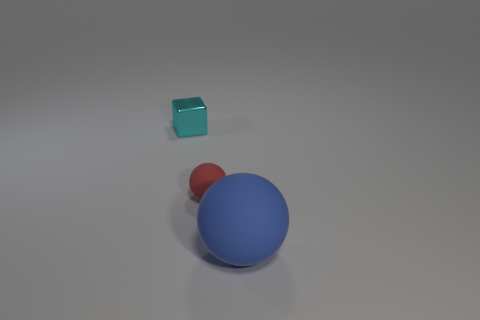Is there any other thing that is the same size as the blue object?
Give a very brief answer. No. What number of objects are small objects in front of the metallic thing or small things that are right of the cyan metal block?
Your answer should be very brief. 1. There is a red rubber thing; what shape is it?
Keep it short and to the point. Sphere. What number of other objects are the same material as the tiny block?
Give a very brief answer. 0. The other blue object that is the same shape as the small matte thing is what size?
Your answer should be compact. Large. There is a thing to the right of the rubber ball behind the matte sphere that is on the right side of the small red rubber ball; what is its material?
Make the answer very short. Rubber. Is there a tiny matte block?
Your answer should be compact. No. There is a metallic cube; is its color the same as the tiny object that is on the right side of the small cyan object?
Your answer should be compact. No. The big matte object has what color?
Offer a very short reply. Blue. Are there any other things that have the same shape as the red rubber object?
Keep it short and to the point. Yes. 